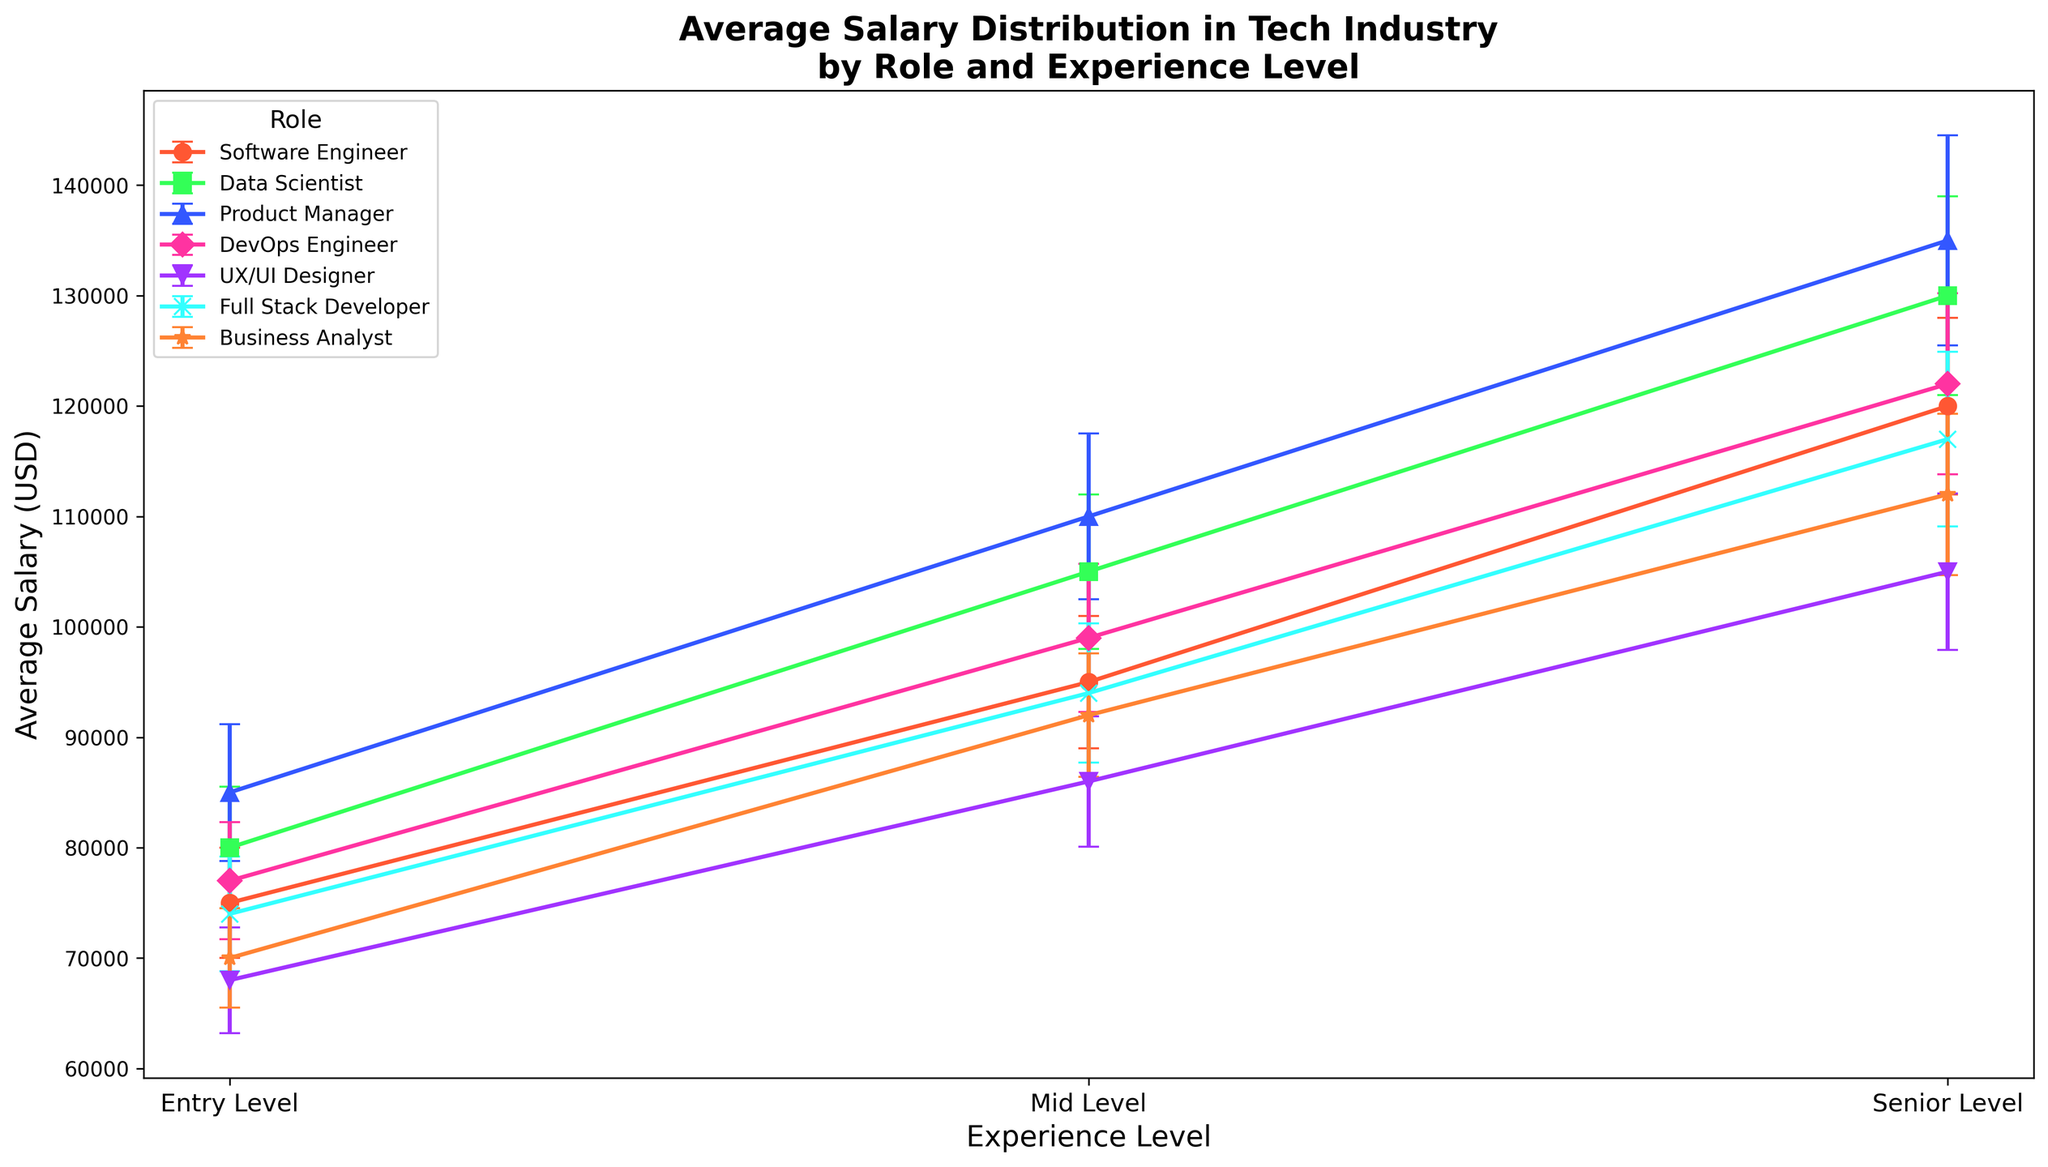What role has the highest average salary at the Senior Level? By looking at the highest point for each category under "Senior Level" on the x-axis, the Product Manager has the highest average salary.
Answer: Product Manager How does the standard deviation of average salaries compare between Mid Level and Senior Level Data Scientists? The standard deviation for Mid Level Data Scientists is 7000, while for Senior Level Data Scientists, it is 9000. By comparing these two values, the standard deviation is higher for Senior Level.
Answer: Senior Level is higher Which entry-level role has the lowest average salary? By looking at the y-values for each role under "Entry Level" on the x-axis, the UX/UI Designer has the lowest average salary.
Answer: UX/UI Designer How much more is the average salary of a Senior Level Software Engineer compared to an Entry Level one? The average salary of a Senior Level Software Engineer is 120000, and an Entry Level one is 75000. The difference is 120000 - 75000 = 45000.
Answer: 45000 Which role shows the smallest variation (smallest error bar) in average salary at the Entry Level? By observing the length of the error bars for each role at "Entry Level" on the x-axis, the Business Analyst has the smallest error bar.
Answer: Business Analyst What is the average salary of a Mid Level Full Stack Developer, and how does it compare to a Mid Level DevOps Engineer? The average salary of a Mid Level Full Stack Developer is 94000, and for a Mid Level DevOps Engineer, it is 99000. Comparing these, the DevOps Engineer earns 5000 more than the Full Stack Developer.
Answer: DevOps Engineer earns 5000 more If you combine the average salaries of an Entry Level UX/UI Designer and an Entry Level Software Engineer, what is the total? The average salary of an Entry Level UX/UI Designer is 68000, and an Entry Level Software Engineer is 75000. Summing these gives 68000 + 75000 = 143000.
Answer: 143000 Which role has the largest range of average salaries from Entry Level to Senior Level? Comparing the differences between Entry Level and Senior Level salaries for each role, Product Manager has the largest range, from 85000 to 135000, giving a range of 50000.
Answer: Product Manager How many roles have an average salary higher than 120000 at the Senior Level? By counting the roles that have average salaries above 120000 at the "Senior Level", there are three: Software Engineer, Data Scientist, Product Manager.
Answer: 3 